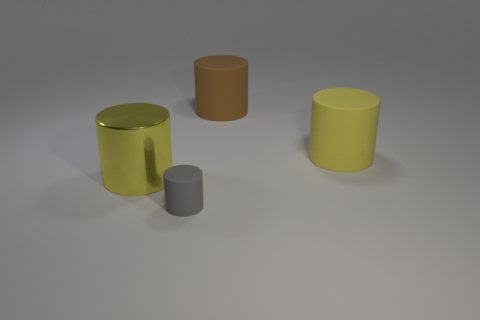Is there any other thing that has the same size as the gray thing?
Give a very brief answer. No. Is the small gray matte thing the same shape as the large brown rubber thing?
Give a very brief answer. Yes. There is a cylinder in front of the yellow object that is in front of the yellow rubber cylinder; what size is it?
Your answer should be very brief. Small. What color is the large shiny thing that is the same shape as the brown rubber object?
Offer a very short reply. Yellow. What number of rubber cylinders have the same color as the big shiny cylinder?
Keep it short and to the point. 1. How big is the gray matte cylinder?
Provide a short and direct response. Small. Do the brown cylinder and the yellow metal object have the same size?
Offer a very short reply. Yes. There is a matte cylinder that is in front of the brown matte object and behind the large metal cylinder; what color is it?
Provide a short and direct response. Yellow. What number of small blocks are made of the same material as the big brown object?
Give a very brief answer. 0. What number of rubber cylinders are there?
Offer a terse response. 3. 